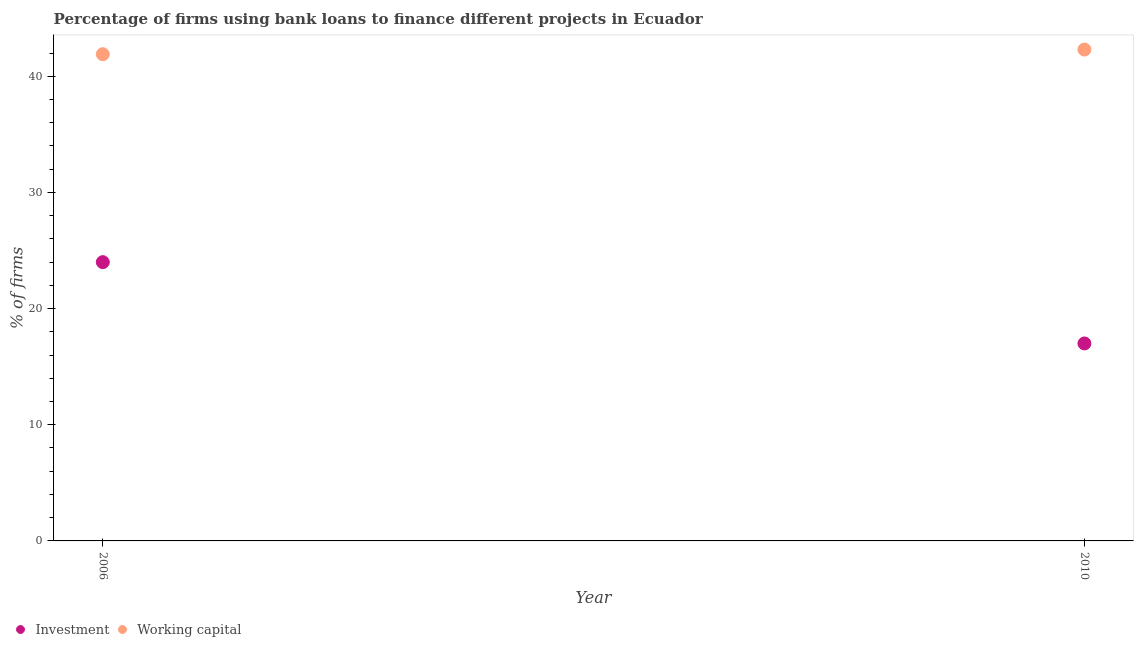What is the percentage of firms using banks to finance investment in 2006?
Your response must be concise. 24. Across all years, what is the maximum percentage of firms using banks to finance working capital?
Your response must be concise. 42.3. Across all years, what is the minimum percentage of firms using banks to finance investment?
Your answer should be very brief. 17. In which year was the percentage of firms using banks to finance investment maximum?
Provide a succinct answer. 2006. In which year was the percentage of firms using banks to finance working capital minimum?
Give a very brief answer. 2006. What is the total percentage of firms using banks to finance working capital in the graph?
Your response must be concise. 84.2. What is the difference between the percentage of firms using banks to finance investment in 2006 and that in 2010?
Give a very brief answer. 7. What is the difference between the percentage of firms using banks to finance working capital in 2010 and the percentage of firms using banks to finance investment in 2006?
Offer a very short reply. 18.3. What is the average percentage of firms using banks to finance working capital per year?
Ensure brevity in your answer.  42.1. In the year 2010, what is the difference between the percentage of firms using banks to finance investment and percentage of firms using banks to finance working capital?
Give a very brief answer. -25.3. In how many years, is the percentage of firms using banks to finance working capital greater than 32 %?
Offer a very short reply. 2. What is the ratio of the percentage of firms using banks to finance investment in 2006 to that in 2010?
Keep it short and to the point. 1.41. Does the percentage of firms using banks to finance investment monotonically increase over the years?
Make the answer very short. No. Is the percentage of firms using banks to finance working capital strictly greater than the percentage of firms using banks to finance investment over the years?
Give a very brief answer. Yes. Is the percentage of firms using banks to finance working capital strictly less than the percentage of firms using banks to finance investment over the years?
Keep it short and to the point. No. How many dotlines are there?
Provide a succinct answer. 2. What is the difference between two consecutive major ticks on the Y-axis?
Ensure brevity in your answer.  10. Are the values on the major ticks of Y-axis written in scientific E-notation?
Give a very brief answer. No. Does the graph contain grids?
Give a very brief answer. No. How are the legend labels stacked?
Your answer should be compact. Horizontal. What is the title of the graph?
Keep it short and to the point. Percentage of firms using bank loans to finance different projects in Ecuador. What is the label or title of the Y-axis?
Give a very brief answer. % of firms. What is the % of firms in Working capital in 2006?
Make the answer very short. 41.9. What is the % of firms of Working capital in 2010?
Your response must be concise. 42.3. Across all years, what is the maximum % of firms of Working capital?
Offer a very short reply. 42.3. Across all years, what is the minimum % of firms in Investment?
Your response must be concise. 17. Across all years, what is the minimum % of firms in Working capital?
Offer a very short reply. 41.9. What is the total % of firms in Investment in the graph?
Give a very brief answer. 41. What is the total % of firms in Working capital in the graph?
Provide a succinct answer. 84.2. What is the difference between the % of firms in Investment in 2006 and that in 2010?
Keep it short and to the point. 7. What is the difference between the % of firms in Working capital in 2006 and that in 2010?
Provide a succinct answer. -0.4. What is the difference between the % of firms in Investment in 2006 and the % of firms in Working capital in 2010?
Offer a very short reply. -18.3. What is the average % of firms in Investment per year?
Ensure brevity in your answer.  20.5. What is the average % of firms in Working capital per year?
Ensure brevity in your answer.  42.1. In the year 2006, what is the difference between the % of firms of Investment and % of firms of Working capital?
Keep it short and to the point. -17.9. In the year 2010, what is the difference between the % of firms of Investment and % of firms of Working capital?
Your answer should be very brief. -25.3. What is the ratio of the % of firms in Investment in 2006 to that in 2010?
Provide a succinct answer. 1.41. What is the ratio of the % of firms of Working capital in 2006 to that in 2010?
Ensure brevity in your answer.  0.99. What is the difference between the highest and the second highest % of firms in Investment?
Keep it short and to the point. 7. 